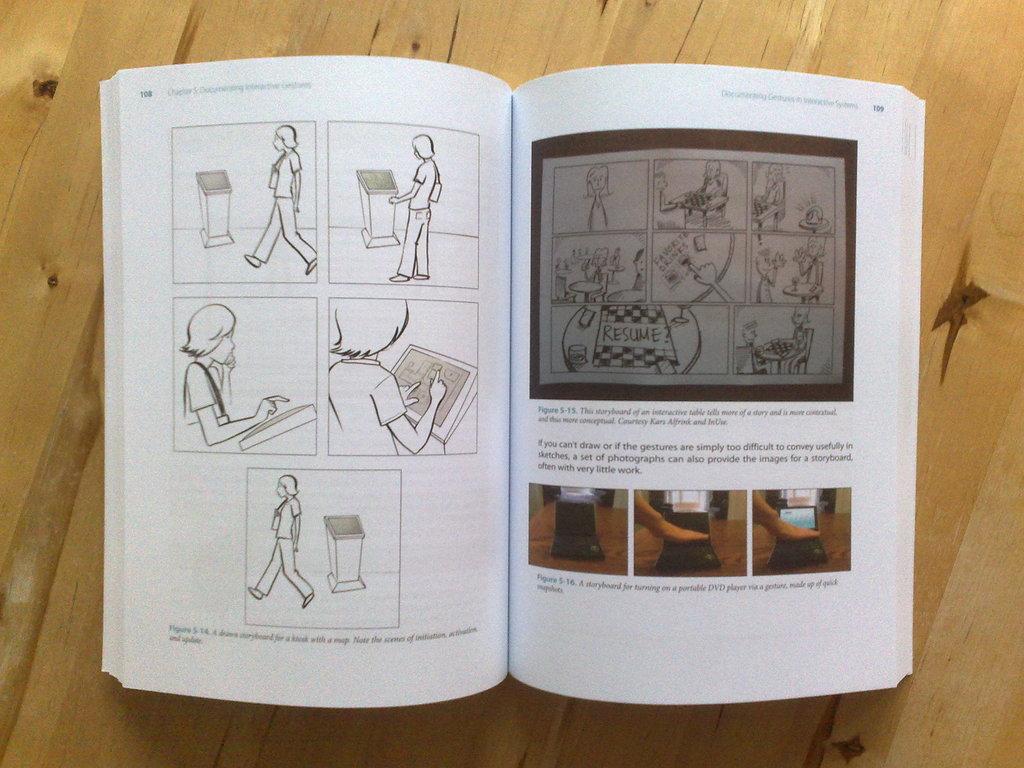What page is the number on the left?
Your answer should be very brief. 108. 